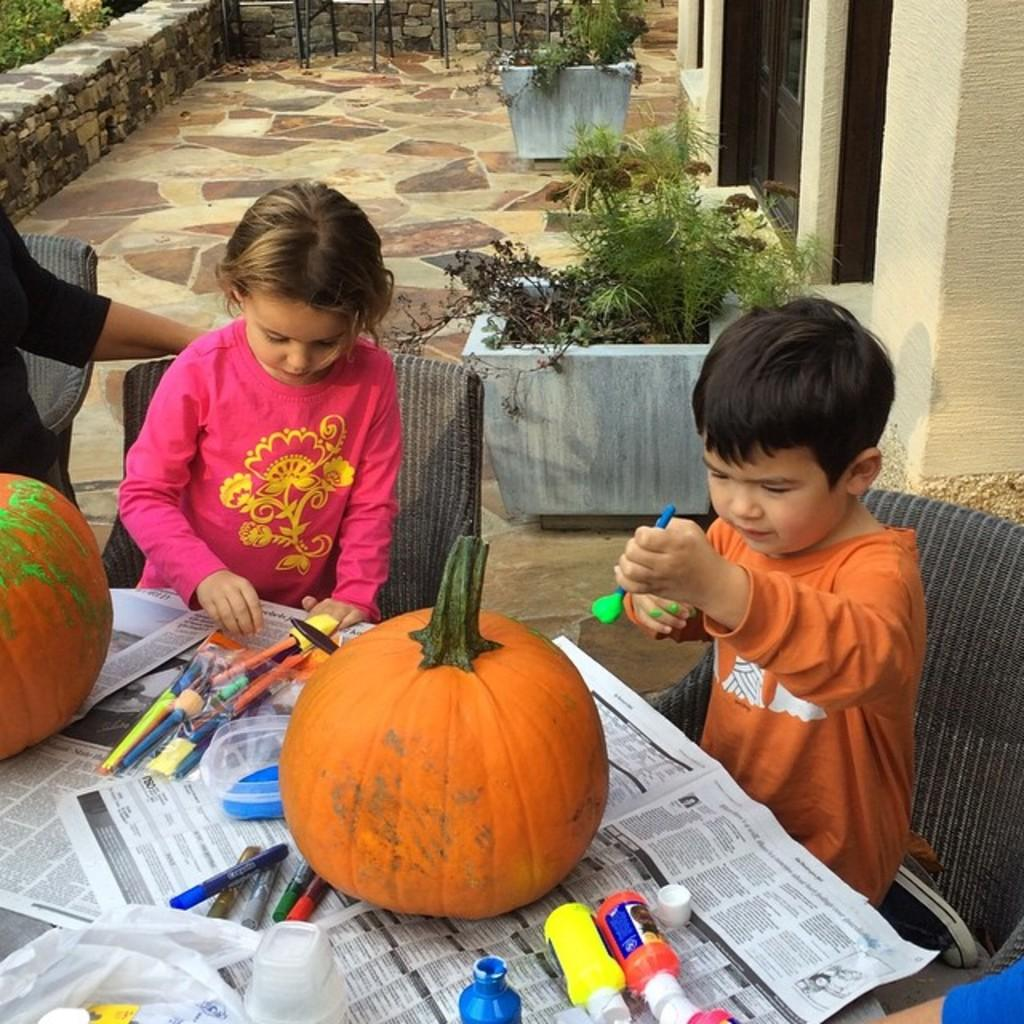Who or what can be seen in the image? There are people in the image. What type of objects are present on the table? Pumpkins, pens, bottles, and other unspecified objects are on the table. What can be found in the background of the image? A: There are plants in the background of the image. What word is being written on the earth in the image? There is no word being written on the earth in the image, as there is no earth or writing present. 